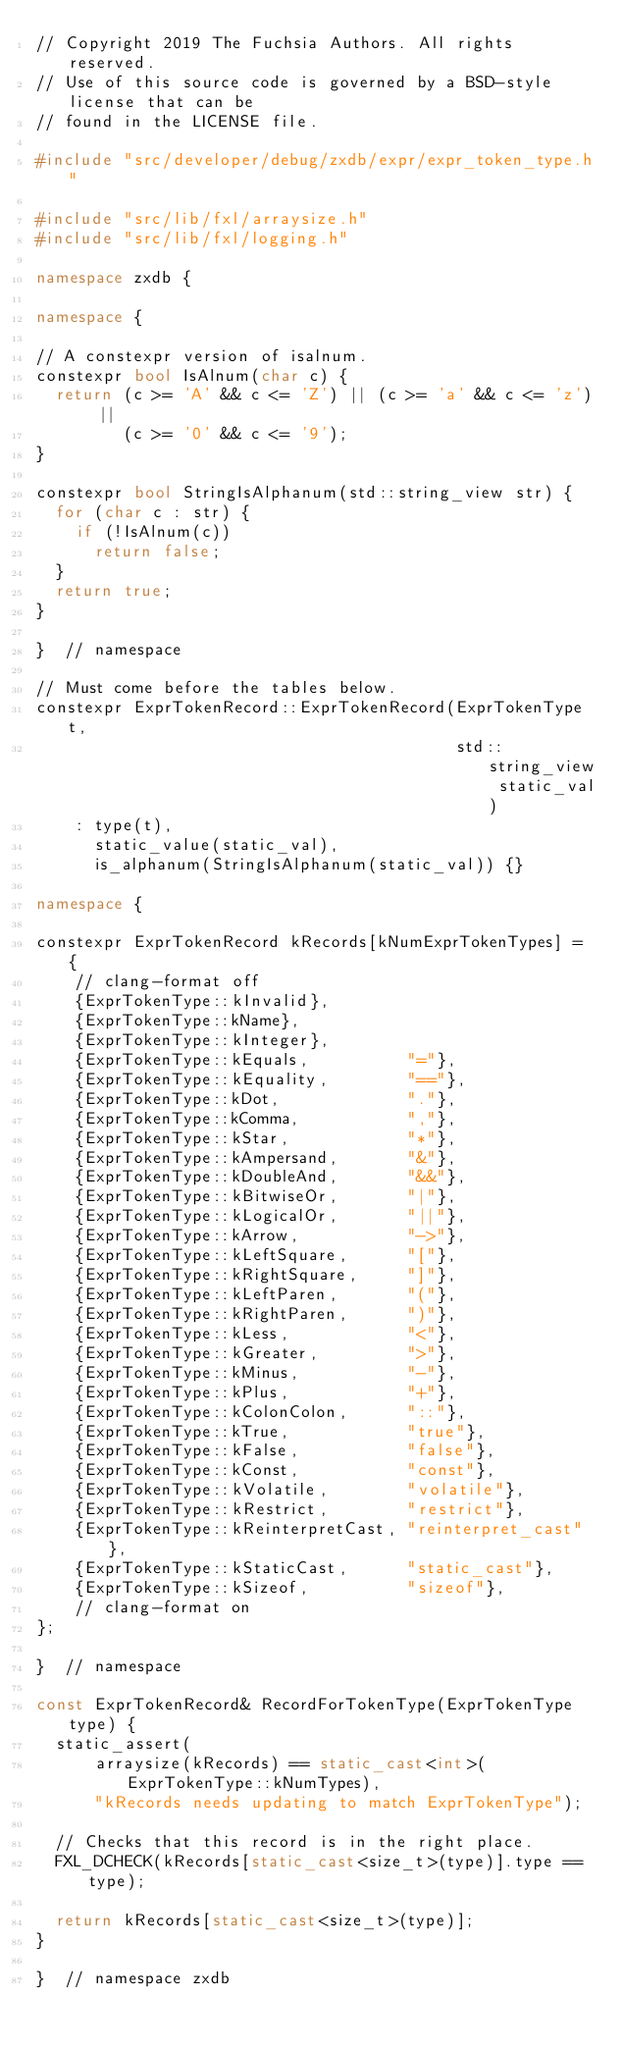<code> <loc_0><loc_0><loc_500><loc_500><_C++_>// Copyright 2019 The Fuchsia Authors. All rights reserved.
// Use of this source code is governed by a BSD-style license that can be
// found in the LICENSE file.

#include "src/developer/debug/zxdb/expr/expr_token_type.h"

#include "src/lib/fxl/arraysize.h"
#include "src/lib/fxl/logging.h"

namespace zxdb {

namespace {

// A constexpr version of isalnum.
constexpr bool IsAlnum(char c) {
  return (c >= 'A' && c <= 'Z') || (c >= 'a' && c <= 'z') ||
         (c >= '0' && c <= '9');
}

constexpr bool StringIsAlphanum(std::string_view str) {
  for (char c : str) {
    if (!IsAlnum(c))
      return false;
  }
  return true;
}

}  // namespace

// Must come before the tables below.
constexpr ExprTokenRecord::ExprTokenRecord(ExprTokenType t,
                                           std::string_view static_val)
    : type(t),
      static_value(static_val),
      is_alphanum(StringIsAlphanum(static_val)) {}

namespace {

constexpr ExprTokenRecord kRecords[kNumExprTokenTypes] = {
    // clang-format off
    {ExprTokenType::kInvalid},
    {ExprTokenType::kName},
    {ExprTokenType::kInteger},
    {ExprTokenType::kEquals,          "="},
    {ExprTokenType::kEquality,        "=="},
    {ExprTokenType::kDot,             "."},
    {ExprTokenType::kComma,           ","},
    {ExprTokenType::kStar,            "*"},
    {ExprTokenType::kAmpersand,       "&"},
    {ExprTokenType::kDoubleAnd,       "&&"},
    {ExprTokenType::kBitwiseOr,       "|"},
    {ExprTokenType::kLogicalOr,       "||"},
    {ExprTokenType::kArrow,           "->"},
    {ExprTokenType::kLeftSquare,      "["},
    {ExprTokenType::kRightSquare,     "]"},
    {ExprTokenType::kLeftParen,       "("},
    {ExprTokenType::kRightParen,      ")"},
    {ExprTokenType::kLess,            "<"},
    {ExprTokenType::kGreater,         ">"},
    {ExprTokenType::kMinus,           "-"},
    {ExprTokenType::kPlus,            "+"},
    {ExprTokenType::kColonColon,      "::"},
    {ExprTokenType::kTrue,            "true"},
    {ExprTokenType::kFalse,           "false"},
    {ExprTokenType::kConst,           "const"},
    {ExprTokenType::kVolatile,        "volatile"},
    {ExprTokenType::kRestrict,        "restrict"},
    {ExprTokenType::kReinterpretCast, "reinterpret_cast"},
    {ExprTokenType::kStaticCast,      "static_cast"},
    {ExprTokenType::kSizeof,          "sizeof"},
    // clang-format on
};

}  // namespace

const ExprTokenRecord& RecordForTokenType(ExprTokenType type) {
  static_assert(
      arraysize(kRecords) == static_cast<int>(ExprTokenType::kNumTypes),
      "kRecords needs updating to match ExprTokenType");

  // Checks that this record is in the right place.
  FXL_DCHECK(kRecords[static_cast<size_t>(type)].type == type);

  return kRecords[static_cast<size_t>(type)];
}

}  // namespace zxdb
</code> 